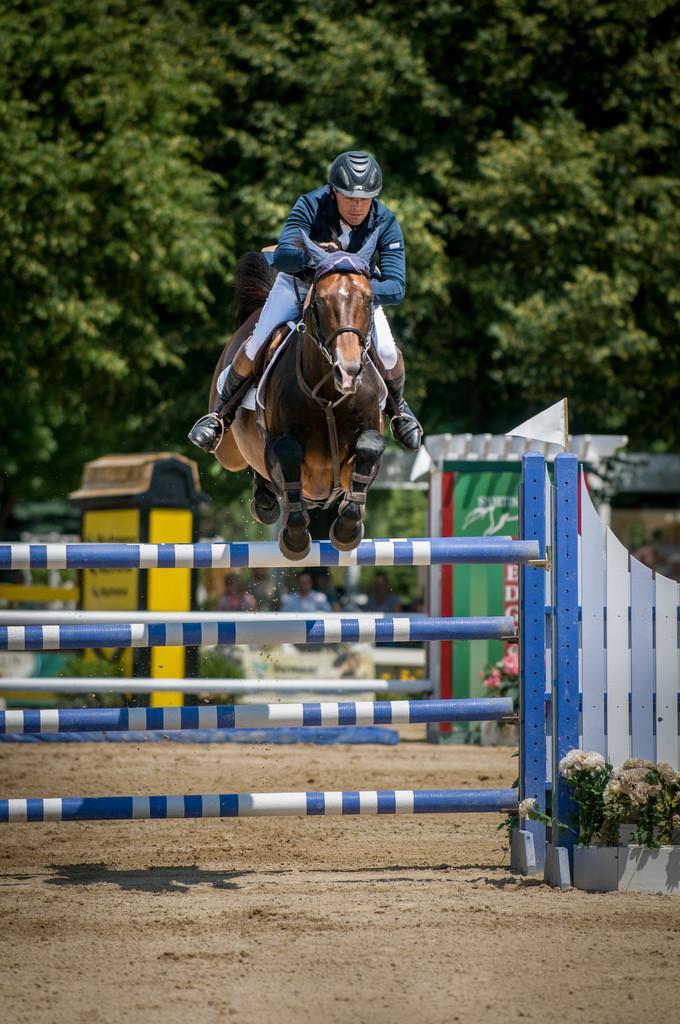Could you give a brief overview of what you see in this image? A person is riding a horse and the horse is jumping a blue color fence, behind the man there are some objects and behind them there are plenty of trees. 